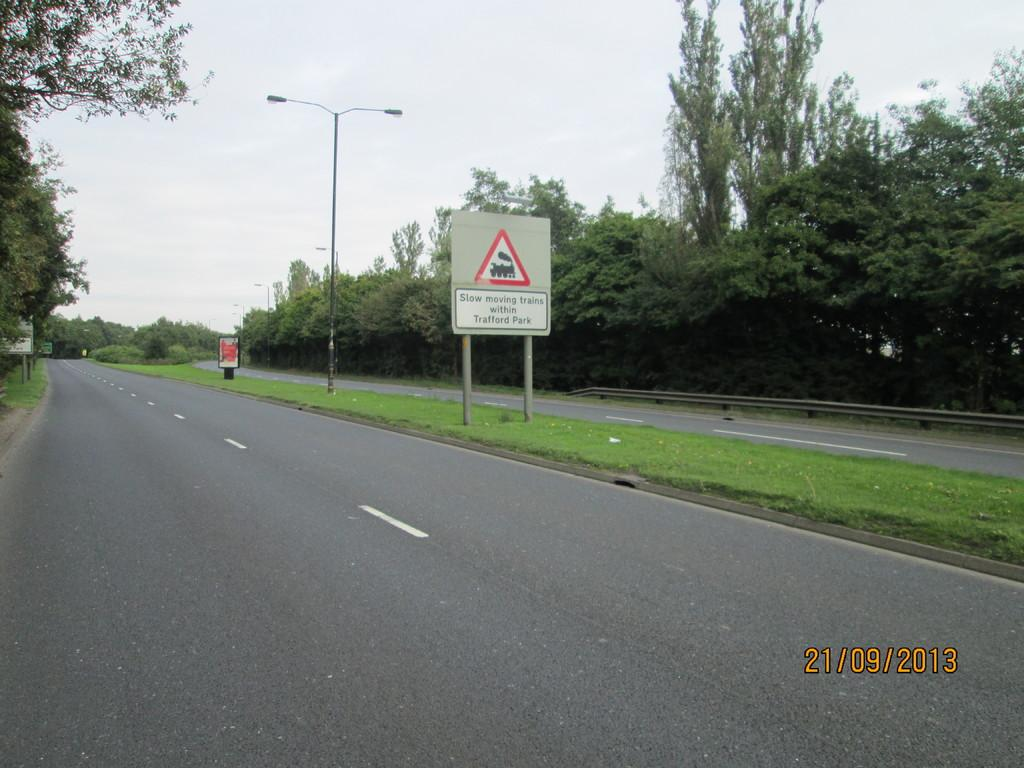<image>
Summarize the visual content of the image. A sign next to a road that says "Slow moving trains within Trafford Park." 